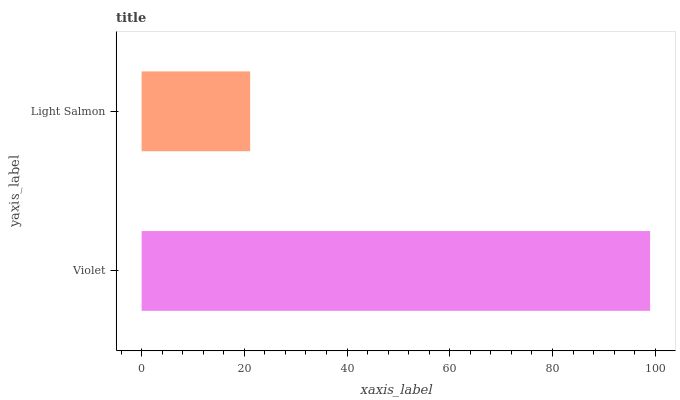Is Light Salmon the minimum?
Answer yes or no. Yes. Is Violet the maximum?
Answer yes or no. Yes. Is Light Salmon the maximum?
Answer yes or no. No. Is Violet greater than Light Salmon?
Answer yes or no. Yes. Is Light Salmon less than Violet?
Answer yes or no. Yes. Is Light Salmon greater than Violet?
Answer yes or no. No. Is Violet less than Light Salmon?
Answer yes or no. No. Is Violet the high median?
Answer yes or no. Yes. Is Light Salmon the low median?
Answer yes or no. Yes. Is Light Salmon the high median?
Answer yes or no. No. Is Violet the low median?
Answer yes or no. No. 